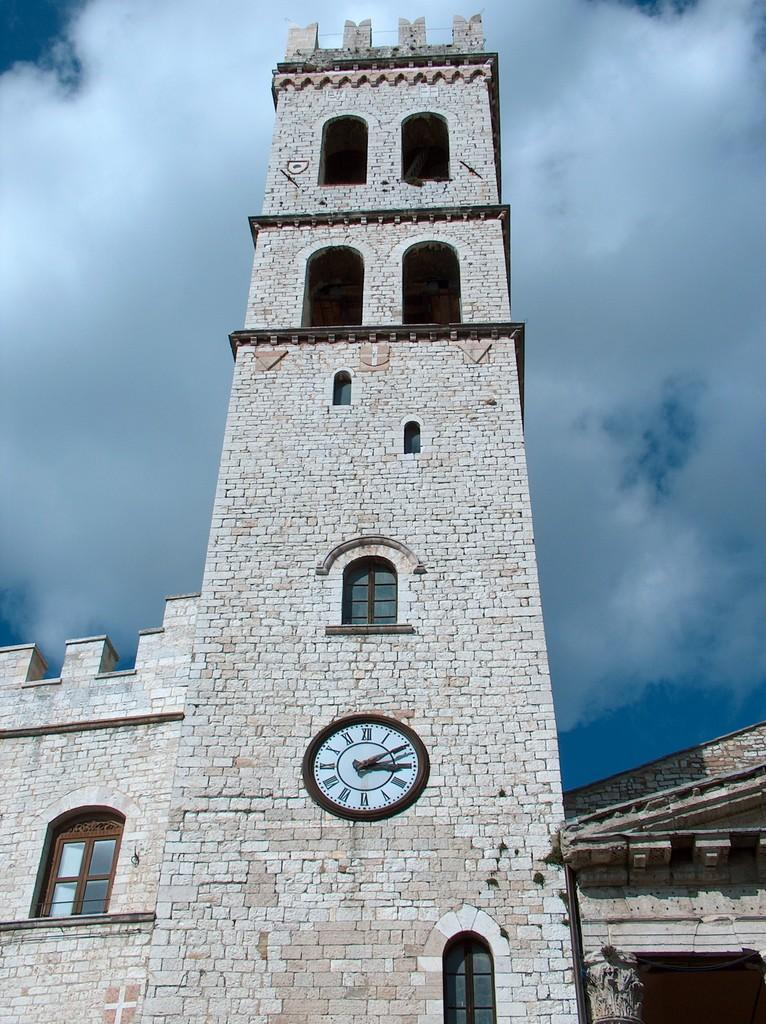What is the main structure in the image? There is a clock tower in the image. What feature is present on the clock tower? The clock tower has a clock. Are there any openings on the clock tower? Yes, there are doors on the clock tower. What type of structures can be seen in the image besides the clock tower? There are buildings with windows in the image. What can be seen in the background of the image? The sky is visible in the background of the image, and clouds are present in the sky. What advice is the clock tower giving to the card in the image? There is no card present in the image, and the clock tower is not capable of giving advice. 